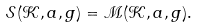<formula> <loc_0><loc_0><loc_500><loc_500>\mathcal { S } ( \mathcal { K } , a , g ) = \mathcal { M } ( \mathcal { K } , a , g ) .</formula> 